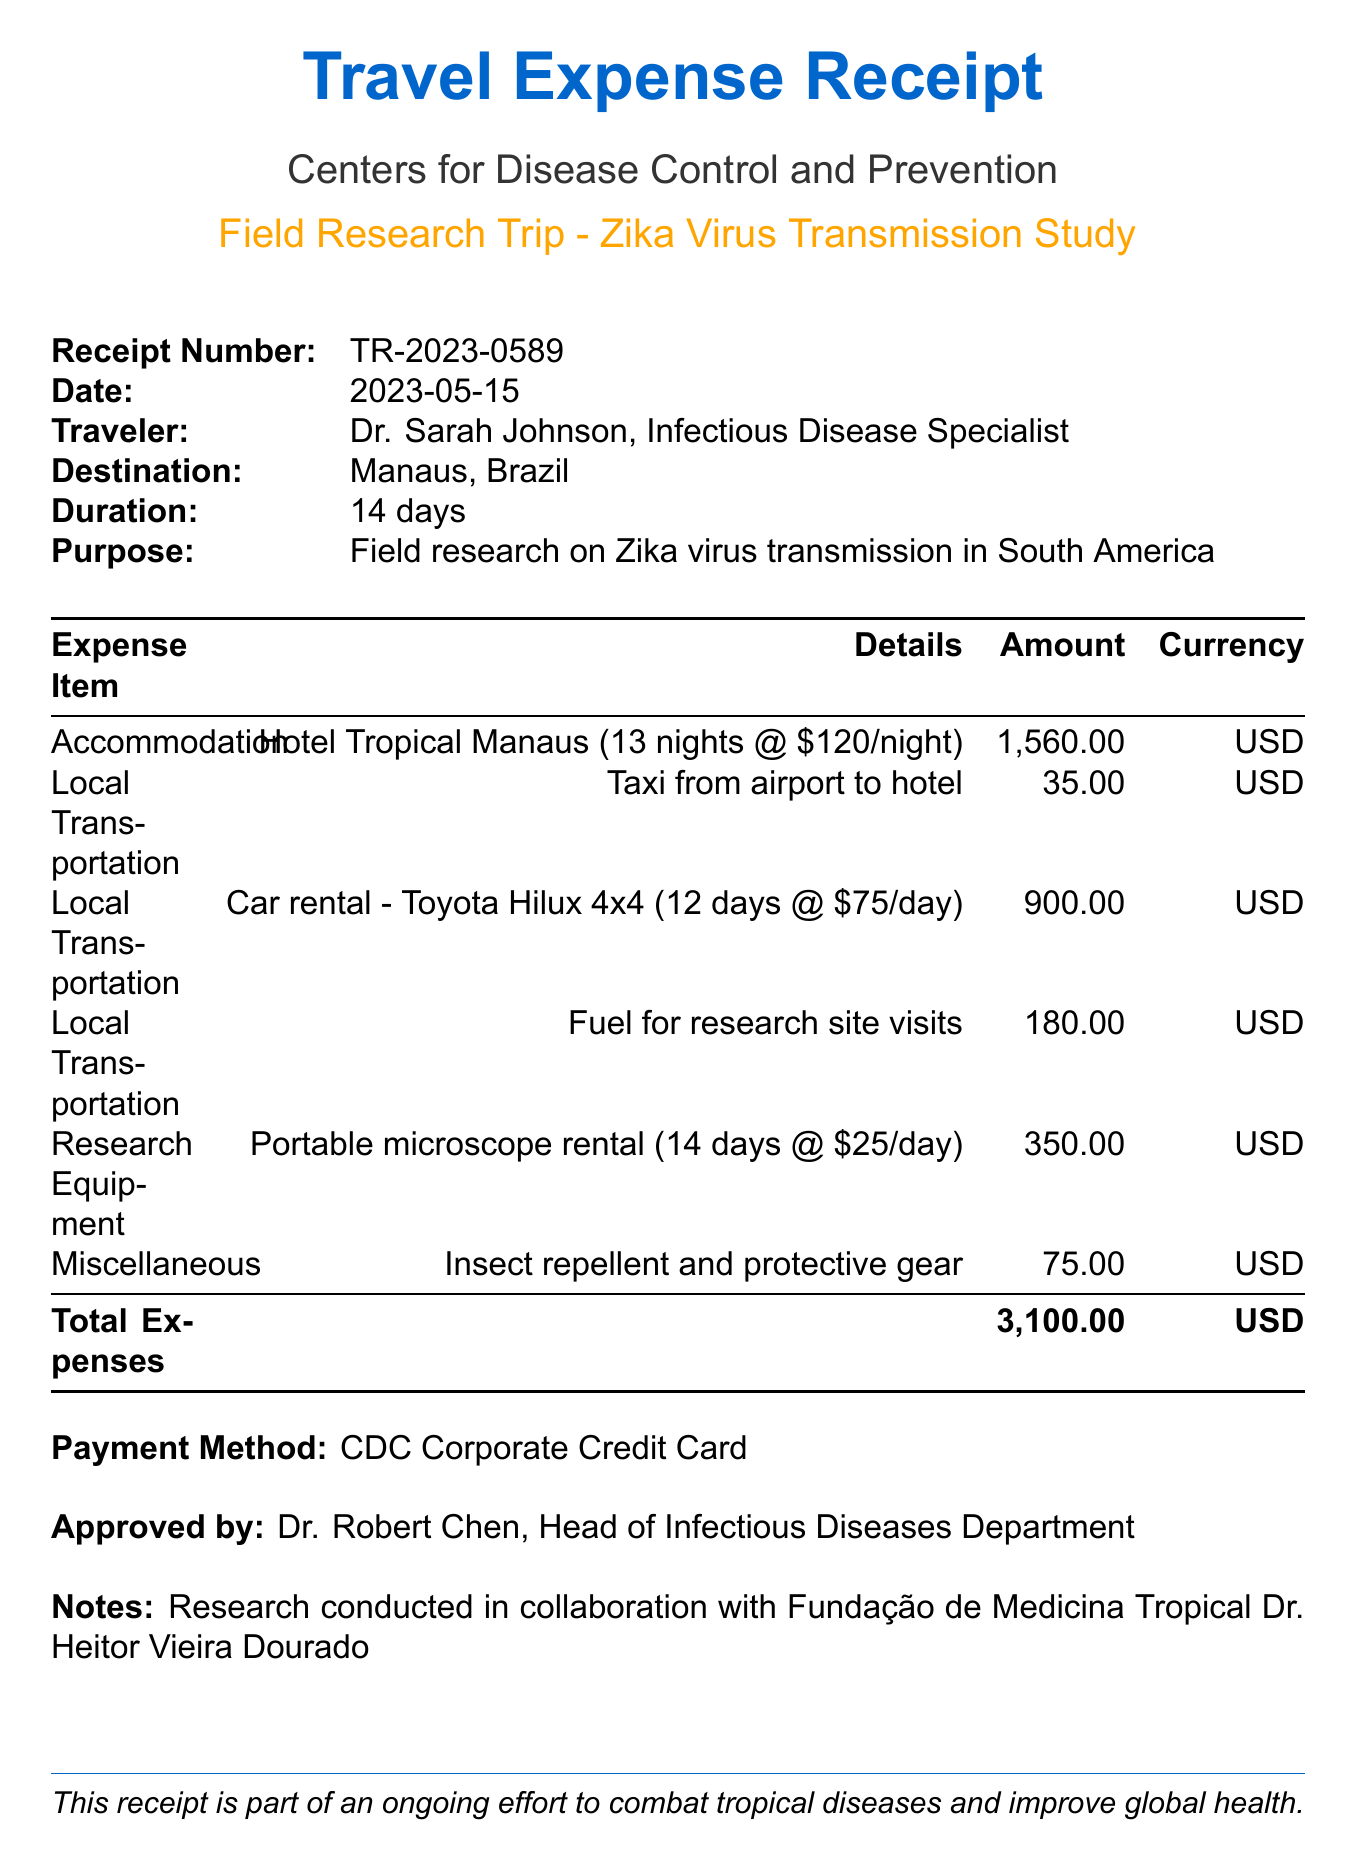What is the receipt number? The receipt number is explicitly stated in the document for reference.
Answer: TR-2023-0589 Who is the traveler? The name of the traveler is clearly indicated in the document.
Answer: Dr. Sarah Johnson What is the destination of the trip? The destination is mentioned in the document under the travel details.
Answer: Manaus, Brazil How many nights did the traveler stay in the hotel? The document specifies the number of nights stayed in accommodation.
Answer: 13 nights What is the total expense reported? The document concludes with the total expenses incurred during the trip.
Answer: 3100.00 What type of vehicle was rented for local transportation? The vehicle description is provided in the local transportation expenses section.
Answer: Toyota Hilux 4x4 What was the purpose of the trip? The purpose of the trip is outlined early in the document.
Answer: Field research on Zika virus transmission in South America Who approved the expenses? The name of the person who approved the receipt is mentioned in the document.
Answer: Dr. Robert Chen How much was spent on fuel for research site visits? The expense for fuel is listed in the local transportation category.
Answer: 180.00 